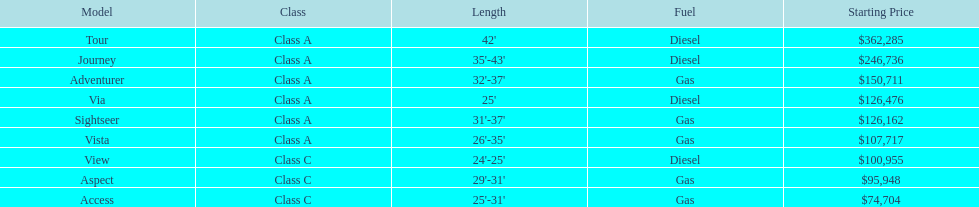What is the number of models with lengths over 30 feet? 7. 